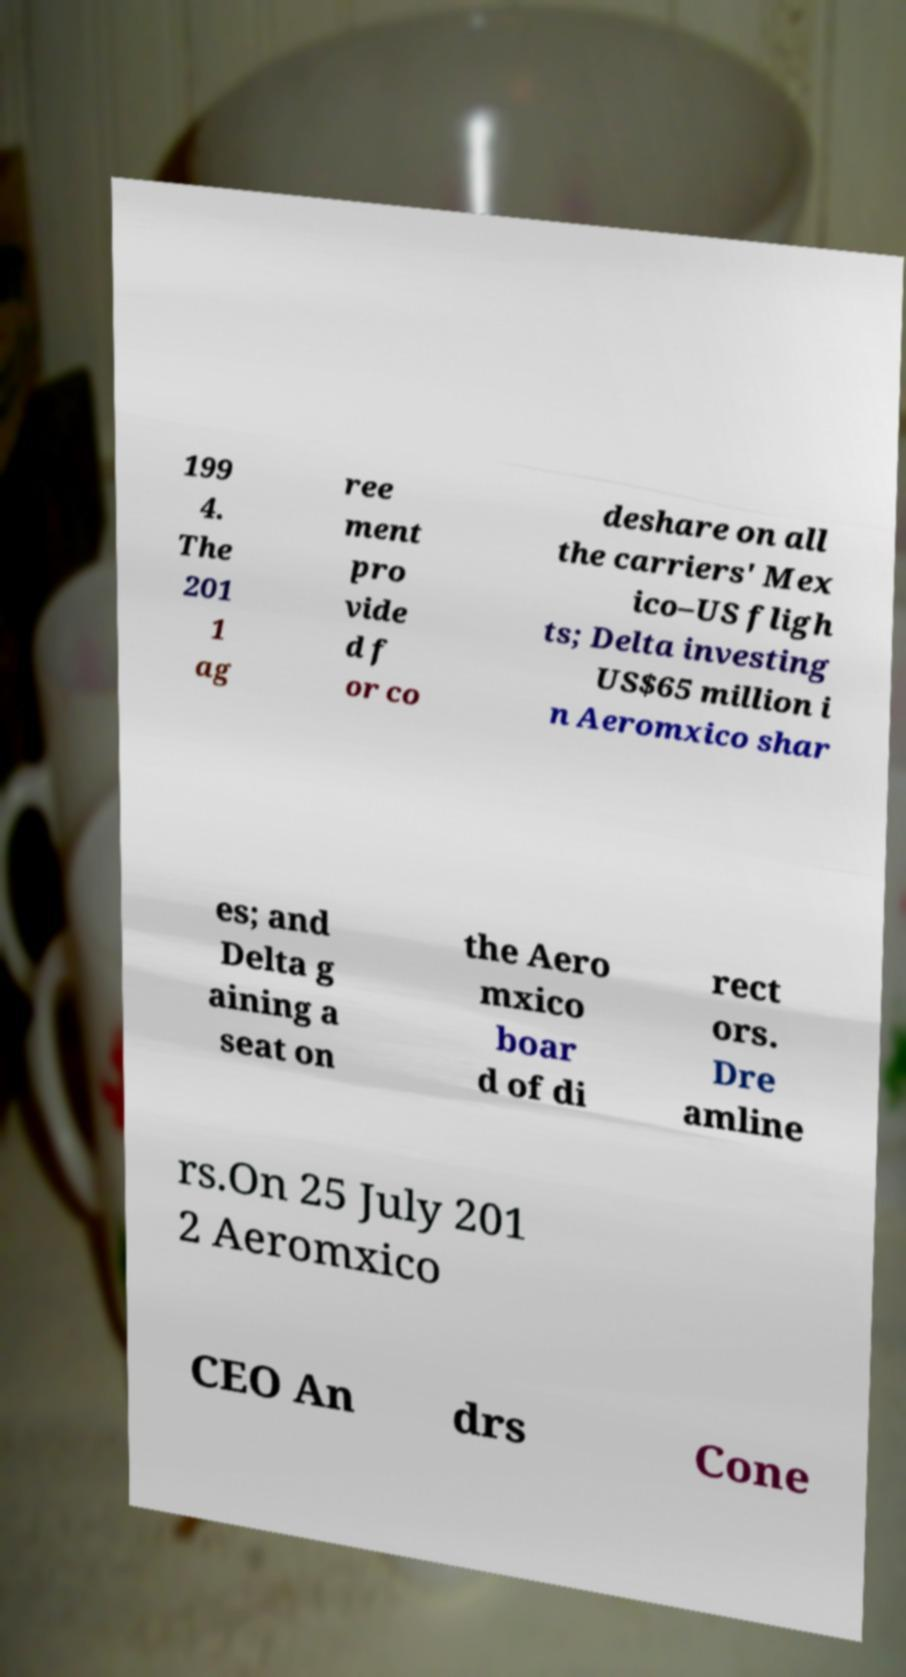Could you extract and type out the text from this image? 199 4. The 201 1 ag ree ment pro vide d f or co deshare on all the carriers' Mex ico–US fligh ts; Delta investing US$65 million i n Aeromxico shar es; and Delta g aining a seat on the Aero mxico boar d of di rect ors. Dre amline rs.On 25 July 201 2 Aeromxico CEO An drs Cone 